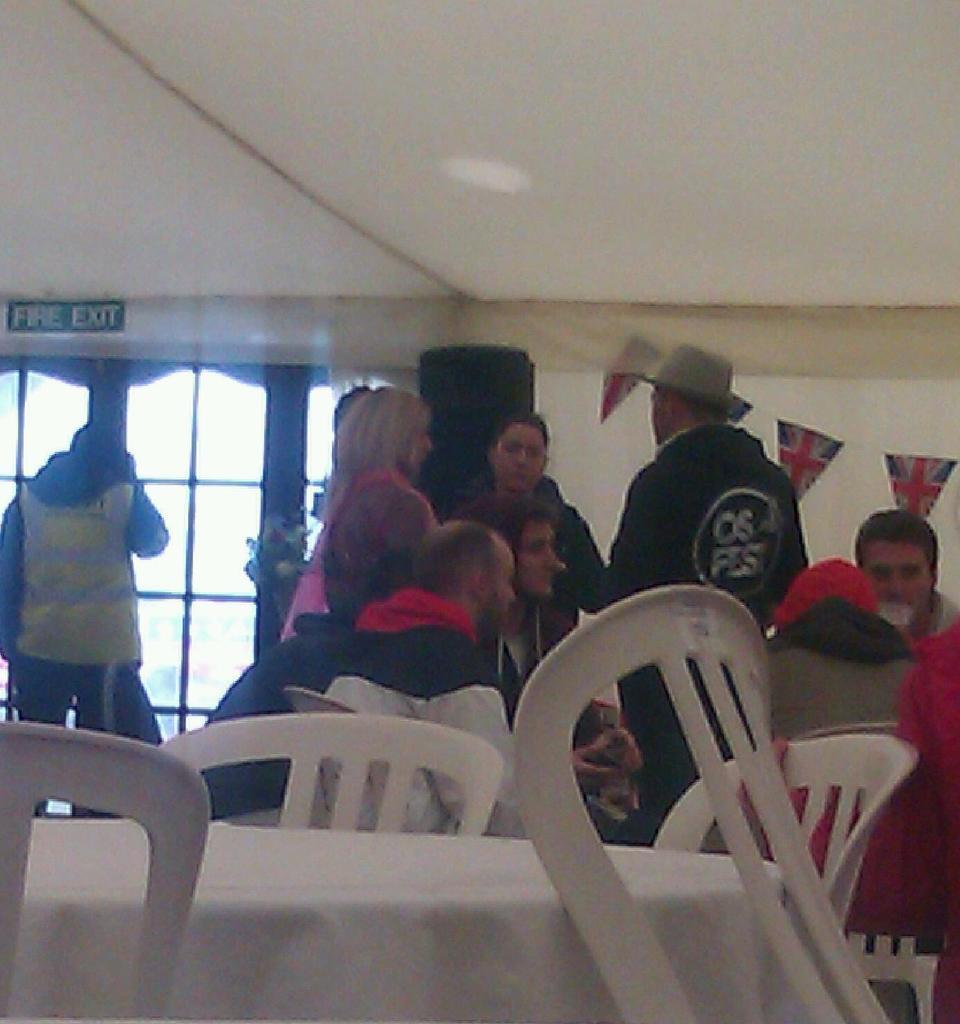In one or two sentences, can you explain what this image depicts? There are some people sitting and standing and there is a fire exit behind them. 